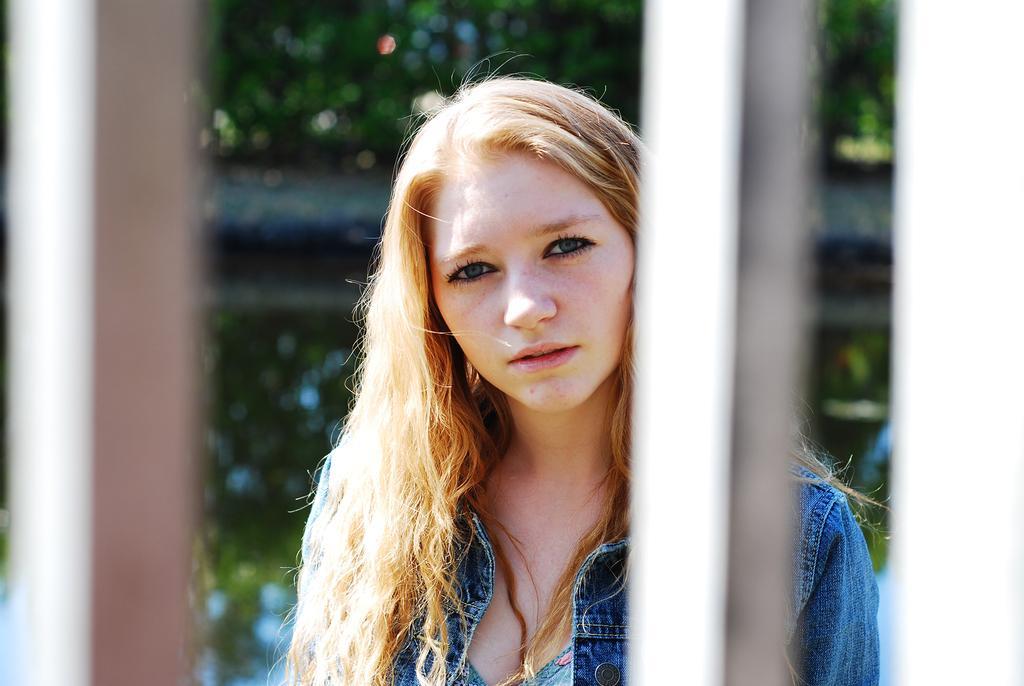Please provide a concise description of this image. In the center of the image we can see a lady. In the background of the image we can see the poles, trees and ground. 